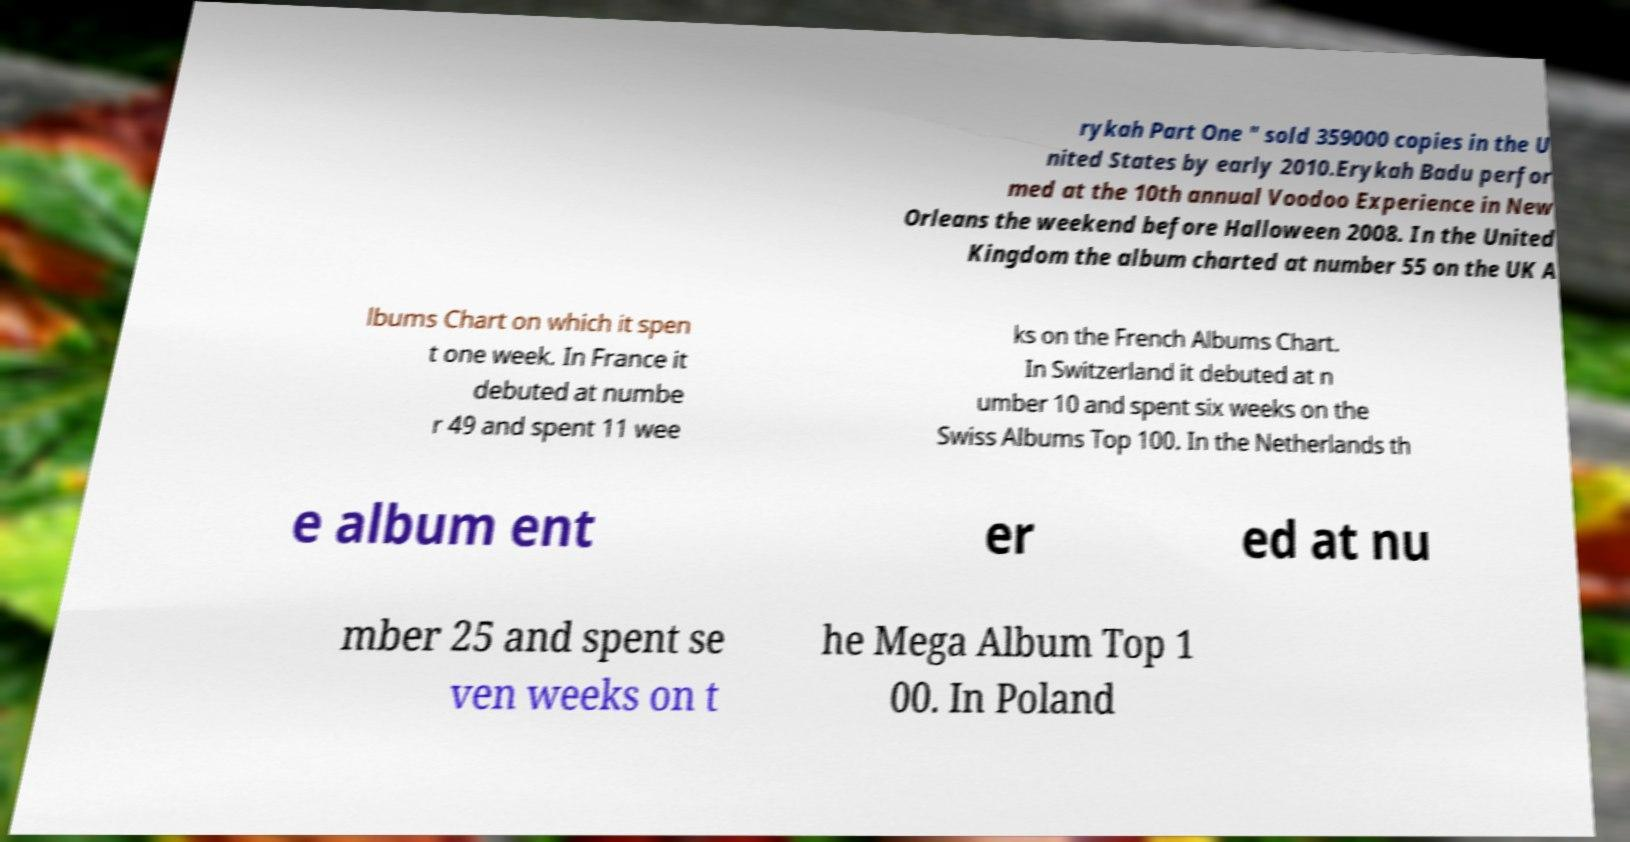Please identify and transcribe the text found in this image. rykah Part One " sold 359000 copies in the U nited States by early 2010.Erykah Badu perfor med at the 10th annual Voodoo Experience in New Orleans the weekend before Halloween 2008. In the United Kingdom the album charted at number 55 on the UK A lbums Chart on which it spen t one week. In France it debuted at numbe r 49 and spent 11 wee ks on the French Albums Chart. In Switzerland it debuted at n umber 10 and spent six weeks on the Swiss Albums Top 100. In the Netherlands th e album ent er ed at nu mber 25 and spent se ven weeks on t he Mega Album Top 1 00. In Poland 